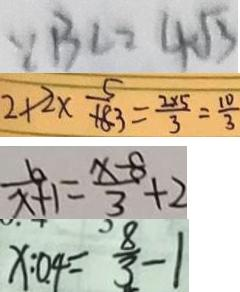Convert formula to latex. <formula><loc_0><loc_0><loc_500><loc_500>\because B C = 4 \sqrt { 3 } 
 2 + 2 \times \frac { 5 } { 3 } = \frac { 2 \times 5 } { 3 } = \frac { 1 0 } { 3 } 
 \frac { b } { x + 1 } = \frac { x - 8 } { 3 } + 2 
 x : 0 . 4 = \frac { 8 } { 3 } - 1</formula> 